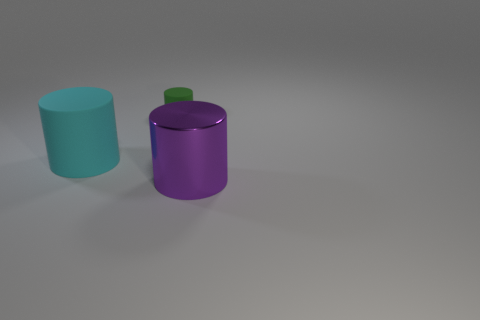Are there fewer big metal cylinders behind the green cylinder than cyan cylinders?
Your answer should be compact. Yes. Are there any other things that have the same size as the green object?
Your answer should be very brief. No. Are the tiny cylinder and the big cyan cylinder made of the same material?
Your answer should be compact. Yes. What number of things are either cylinders that are in front of the cyan object or things behind the purple metallic object?
Your answer should be very brief. 3. Are there any other metal cylinders of the same size as the cyan cylinder?
Offer a very short reply. Yes. What is the color of the other matte object that is the same shape as the tiny green object?
Ensure brevity in your answer.  Cyan. There is a rubber cylinder that is on the left side of the tiny green matte cylinder; is there a cyan thing left of it?
Keep it short and to the point. No. Is the shape of the large object that is on the left side of the metallic thing the same as  the tiny rubber thing?
Your answer should be very brief. Yes. How many cyan cylinders have the same material as the tiny green thing?
Make the answer very short. 1. What number of big purple things are there?
Your answer should be very brief. 1. 